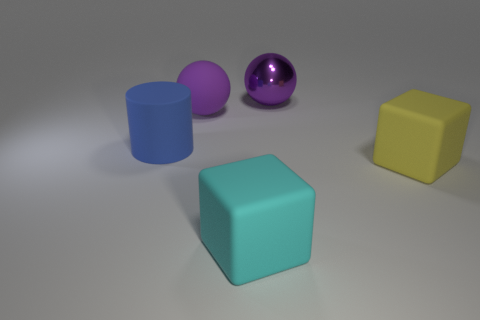Does the matte thing behind the big blue object have the same color as the big ball to the right of the cyan matte object?
Keep it short and to the point. Yes. What number of big matte balls are the same color as the big metallic ball?
Your answer should be very brief. 1. Do the rubber object that is behind the big blue rubber object and the large shiny ball have the same color?
Keep it short and to the point. Yes. There is a big thing that is both in front of the blue rubber thing and left of the yellow object; what is its material?
Make the answer very short. Rubber. Is there a large yellow object on the right side of the large purple sphere to the right of the big cyan matte thing?
Keep it short and to the point. Yes. Is the material of the yellow cube the same as the big cylinder?
Provide a short and direct response. Yes. What is the shape of the large rubber thing that is behind the large yellow block and in front of the large matte sphere?
Offer a very short reply. Cylinder. What size is the ball behind the ball that is to the left of the large purple metal object?
Your answer should be very brief. Large. How many other objects are the same shape as the big purple shiny thing?
Keep it short and to the point. 1. Is the shiny ball the same color as the matte sphere?
Provide a short and direct response. Yes. 